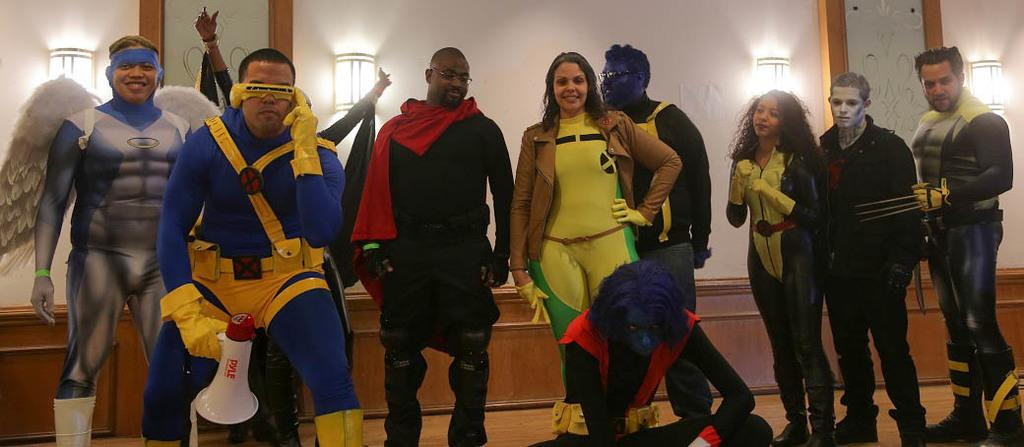Who or what can be seen in the image? There are people in the image. What are the people wearing? The people are wearing different costumes. What else is visible in the image besides the people? There are lights visible in the image. What type of structure can be seen in the image? There is a wall in the image. What type of dock can be seen in the image? There is no dock present in the image. How long is the trail visible in the image? There is no trail present in the image. 